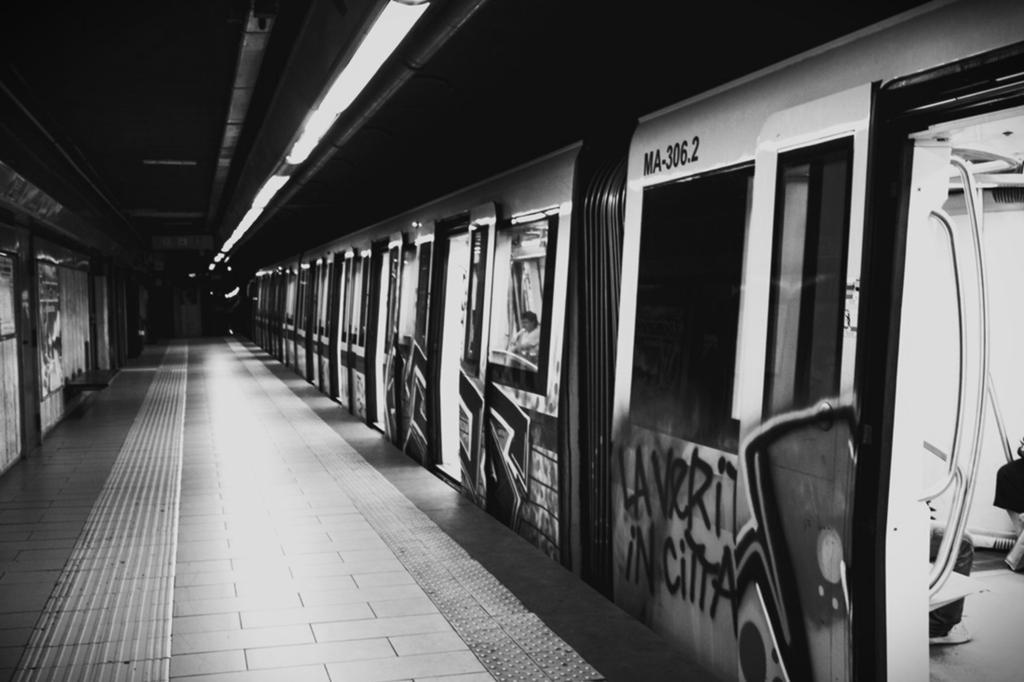Could you give a brief overview of what you see in this image? In this picture on the right side, we can see a train on the railway track & on the left side we see the railway platform. 